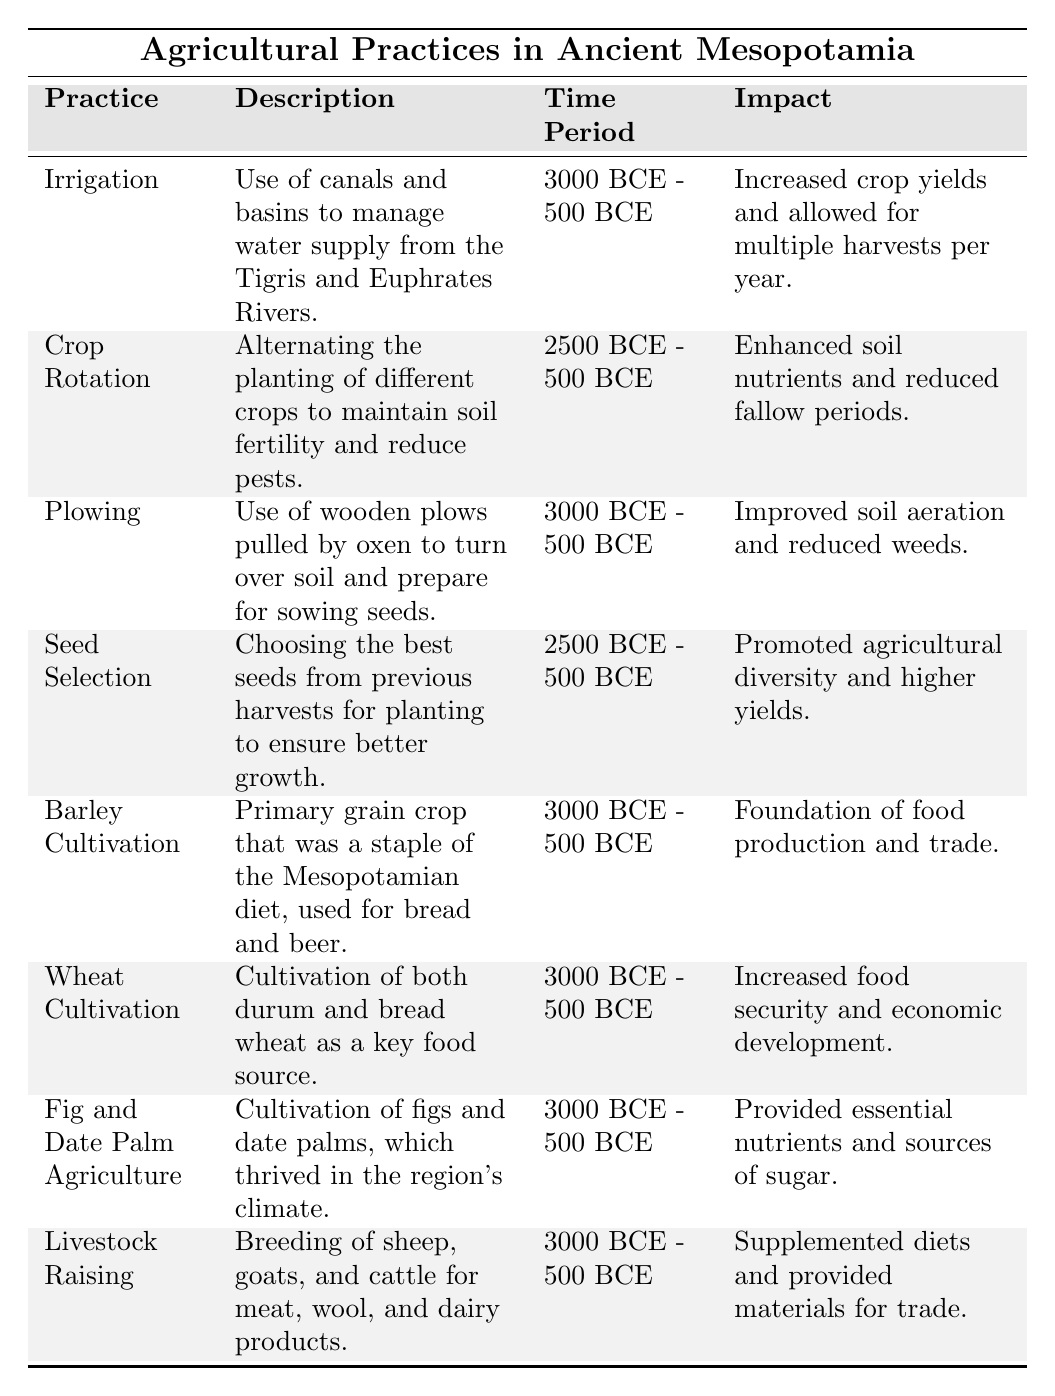What time period does irrigation cover in ancient Mesopotamia? The table indicates that irrigation was practiced from 3000 BCE to 500 BCE.
Answer: 3000 BCE - 500 BCE Which agricultural practice aimed to maintain soil fertility? The practice of crop rotation is specifically designed to maintain soil fertility by alternating the planting of different crops.
Answer: Crop Rotation What was the impact of seed selection on agriculture in Mesopotamia? According to the table, seed selection promoted agricultural diversity and led to higher yields by choosing the best seeds from previous harvests.
Answer: Promoted agricultural diversity and higher yields How many agricultural practices are mentioned in the table? By counting the entries in the table, there are a total of 8 agricultural practices listed for ancient Mesopotamia.
Answer: 8 Which two crops were primarily cultivated in ancient Mesopotamia? The table lists barley and wheat as primary crops cultivated during this time.
Answer: Barley and wheat Was livestock raising practiced during the same time period as irrigation? The table shows that both livestock raising and irrigation were practiced from 3000 BCE to 500 BCE, indicating they occurred during the same time period.
Answer: Yes What agricultural practice was noted for improving soil aeration? The table specifies that plowing, using wooden plows pulled by oxen, improved soil aeration by turning over the soil.
Answer: Plowing Which agricultural practice had the least time span according to the table? Both crop rotation and seed selection were practiced from 2500 BCE to 500 BCE, making their time span shorter than others that began in 3000 BCE.
Answer: Crop Rotation and Seed Selection Compare the impact of barley cultivation and wheat cultivation. Barley cultivation laid the foundation of food production and trade, while wheat cultivation increased food security and stimulated economic development. Both are crucial but serve slightly different impacts.
Answer: Different impacts: Barley for trade, wheat for food security What can be concluded about the role of irrigation in crop yields? Irrigation significantly increased crop yields and allowed for multiple harvests per year, showcasing its critical importance in agricultural practices.
Answer: Increased crop yields and allowed for multiple harvests Which agricultural practice included the use of oxen? The practice that involved the use of oxen is plowing, as detailed in the table.
Answer: Plowing 